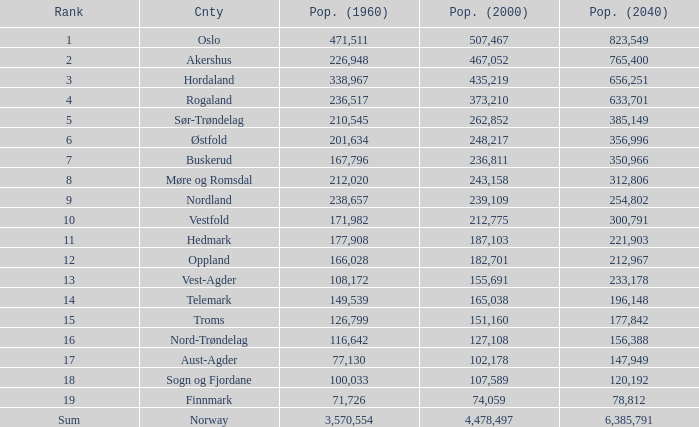What was Oslo's population in 1960, with a population of 507,467 in 2000? None. 